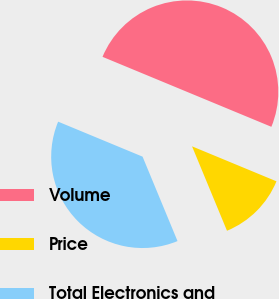Convert chart. <chart><loc_0><loc_0><loc_500><loc_500><pie_chart><fcel>Volume<fcel>Price<fcel>Total Electronics and<nl><fcel>50.0%<fcel>12.5%<fcel>37.5%<nl></chart> 